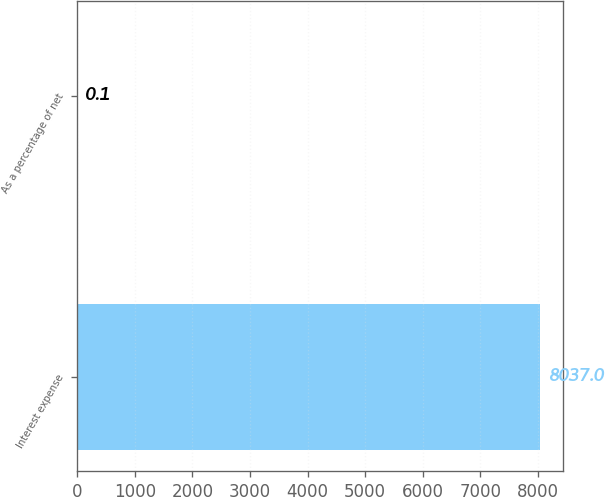Convert chart. <chart><loc_0><loc_0><loc_500><loc_500><bar_chart><fcel>Interest expense<fcel>As a percentage of net<nl><fcel>8037<fcel>0.1<nl></chart> 